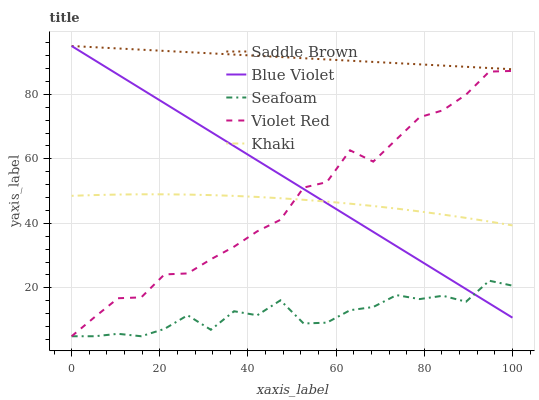Does Seafoam have the minimum area under the curve?
Answer yes or no. Yes. Does Saddle Brown have the maximum area under the curve?
Answer yes or no. Yes. Does Khaki have the minimum area under the curve?
Answer yes or no. No. Does Khaki have the maximum area under the curve?
Answer yes or no. No. Is Blue Violet the smoothest?
Answer yes or no. Yes. Is Seafoam the roughest?
Answer yes or no. Yes. Is Khaki the smoothest?
Answer yes or no. No. Is Khaki the roughest?
Answer yes or no. No. Does Violet Red have the lowest value?
Answer yes or no. Yes. Does Khaki have the lowest value?
Answer yes or no. No. Does Blue Violet have the highest value?
Answer yes or no. Yes. Does Khaki have the highest value?
Answer yes or no. No. Is Seafoam less than Khaki?
Answer yes or no. Yes. Is Khaki greater than Seafoam?
Answer yes or no. Yes. Does Khaki intersect Violet Red?
Answer yes or no. Yes. Is Khaki less than Violet Red?
Answer yes or no. No. Is Khaki greater than Violet Red?
Answer yes or no. No. Does Seafoam intersect Khaki?
Answer yes or no. No. 